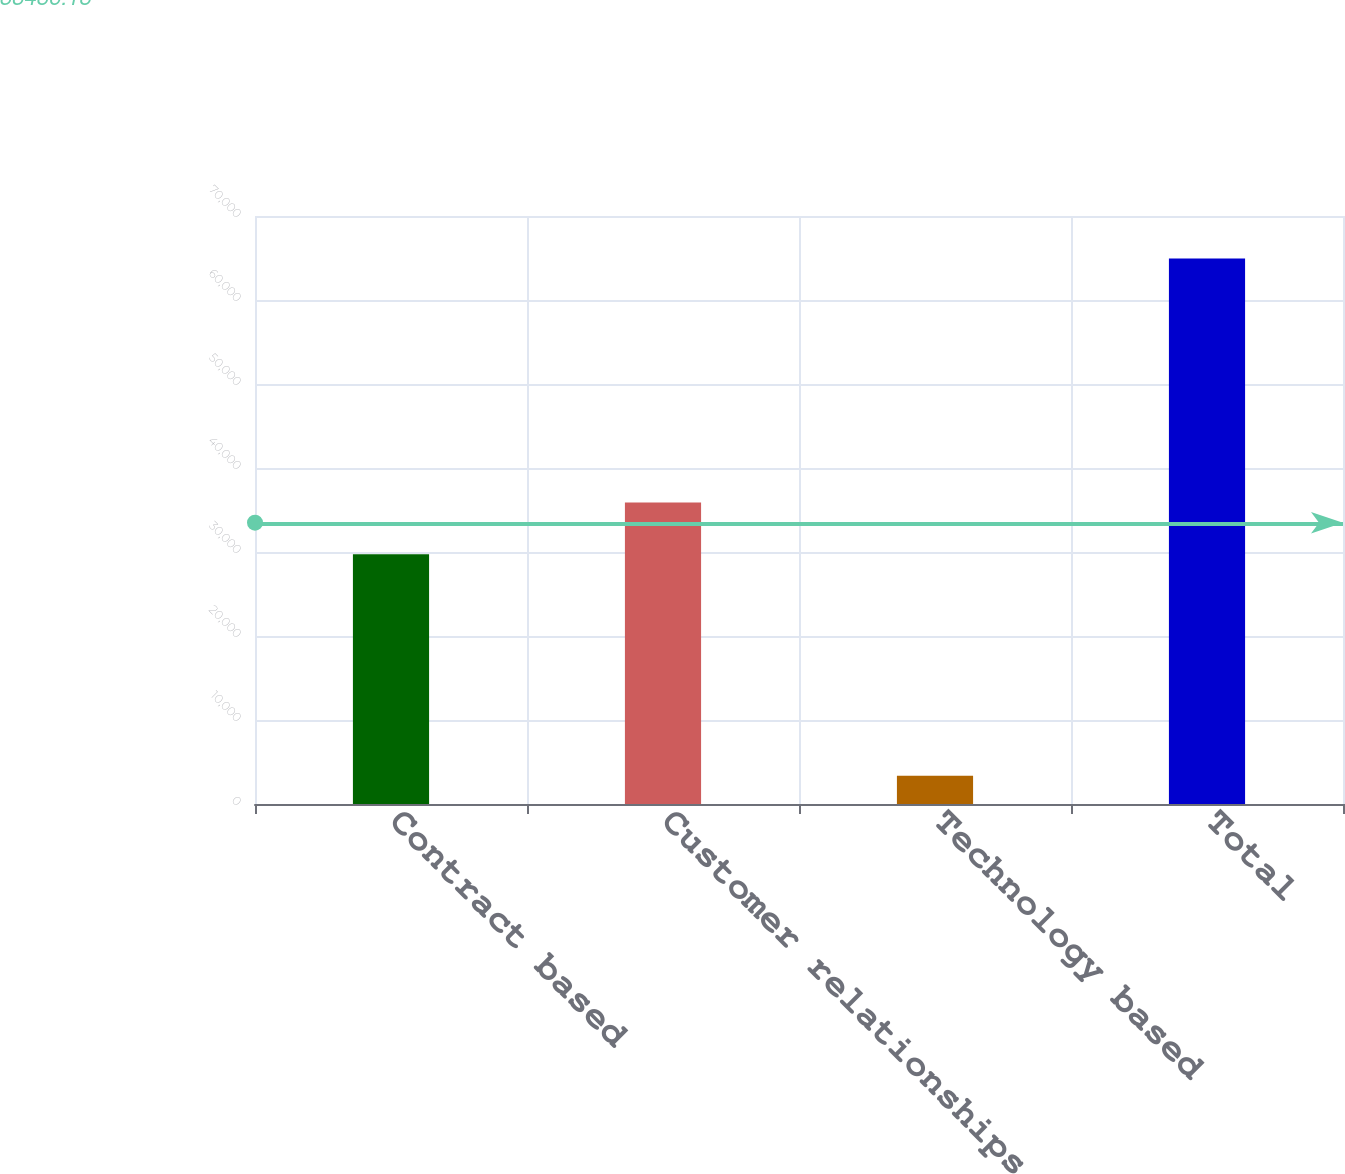Convert chart to OTSL. <chart><loc_0><loc_0><loc_500><loc_500><bar_chart><fcel>Contract based<fcel>Customer relationships<fcel>Technology based<fcel>Total<nl><fcel>29739<fcel>35894.7<fcel>3377<fcel>64934<nl></chart> 